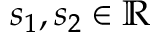<formula> <loc_0><loc_0><loc_500><loc_500>s _ { 1 } , s _ { 2 } \in \mathbb { R }</formula> 